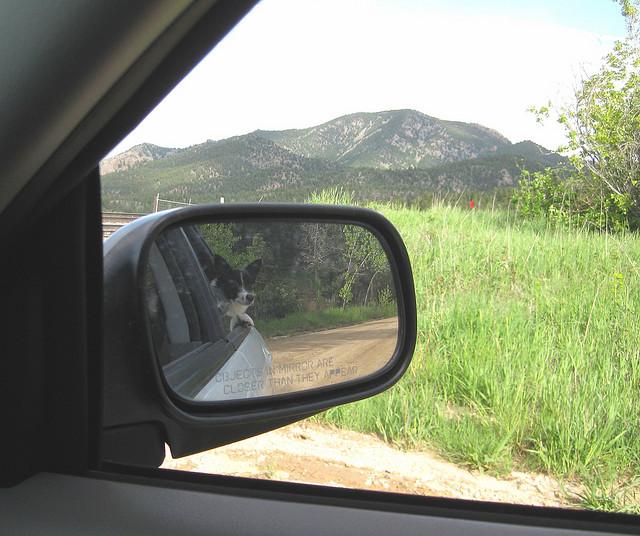Is this the Mojave Desert?
Quick response, please. No. Is the mirror on the driver's side?
Be succinct. No. Is the dog curious about outside?
Be succinct. Yes. IS this in the suburbs?
Answer briefly. No. What are we able to see in the mirror?
Write a very short answer. Dog. Is there more than 1 car?
Short answer required. No. 